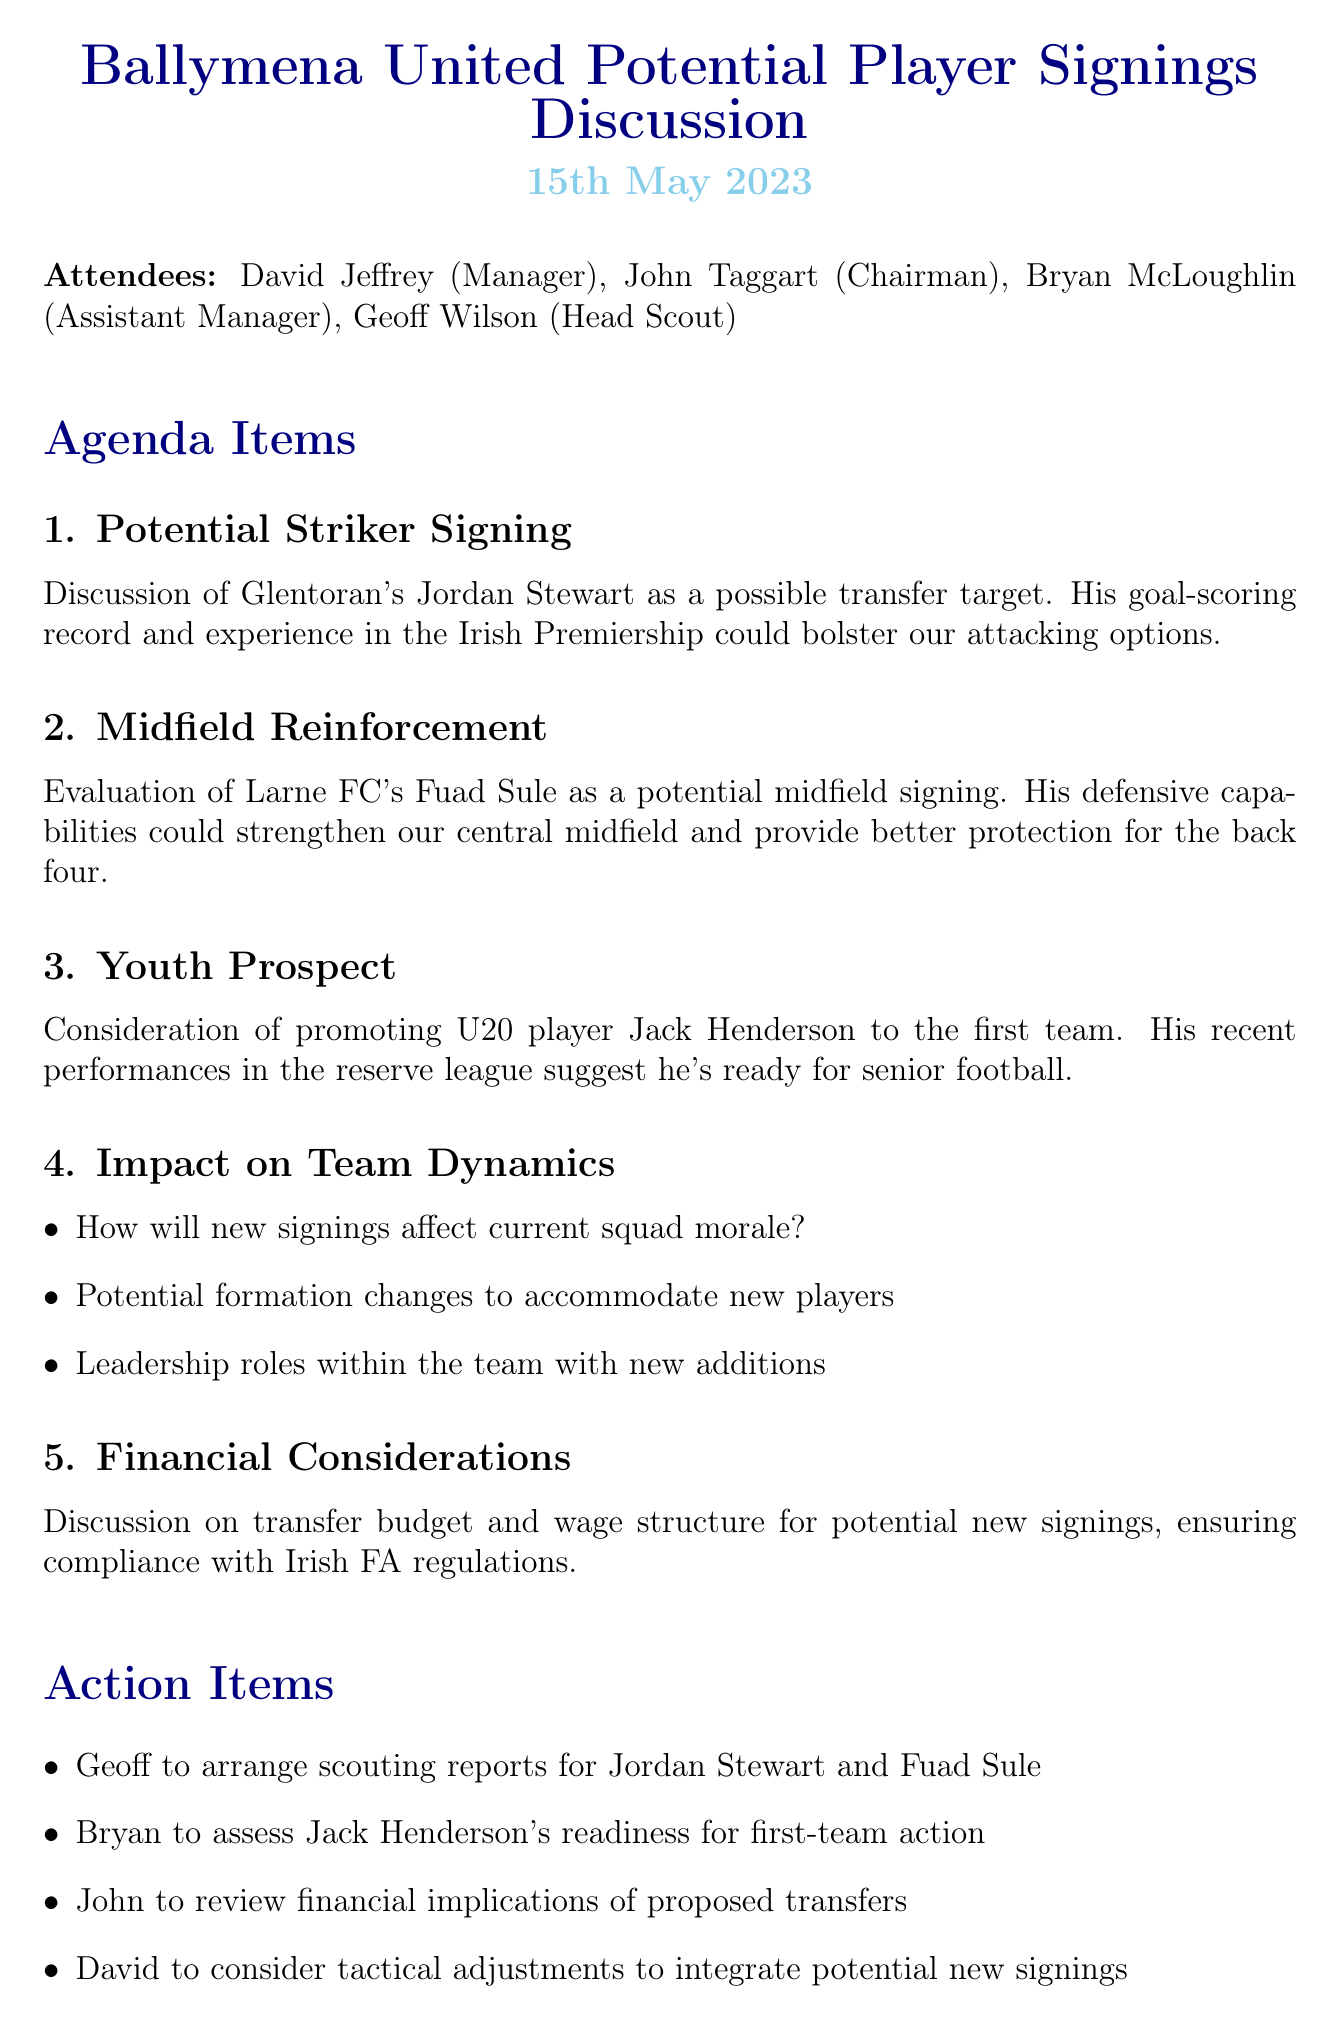What is the date of the meeting? The date of the meeting is clearly stated in the document as "15th May 2023."
Answer: 15th May 2023 Who is the Head Scout? The document lists "Geoff Wilson" as the Head Scout in the attendees section.
Answer: Geoff Wilson Which player is being considered for a striker signing? The minutes mention "Jordan Stewart" from Glentoran as a potential striker signing.
Answer: Jordan Stewart What is the first action item listed? The first action item states that "Geoff to arrange scouting reports for Jordan Stewart and Fuad Sule."
Answer: Geoff to arrange scouting reports for Jordan Stewart and Fuad Sule What are the financial considerations discussed? The document notes a discussion on "transfer budget and wage structure for potential new signings."
Answer: transfer budget and wage structure for potential new signings How might new signings affect the team? The document raises points such as "How will new signings affect current squad morale?"
Answer: current squad morale Which youth player is being considered for promotion? "Jack Henderson" is the U20 player mentioned for potential promotion to the first team.
Answer: Jack Henderson What topic is discussed under Impact on Team Dynamics? The minutes include various questions concerning team dynamics like "Potential formation changes to accommodate new players."
Answer: Potential formation changes to accommodate new players 